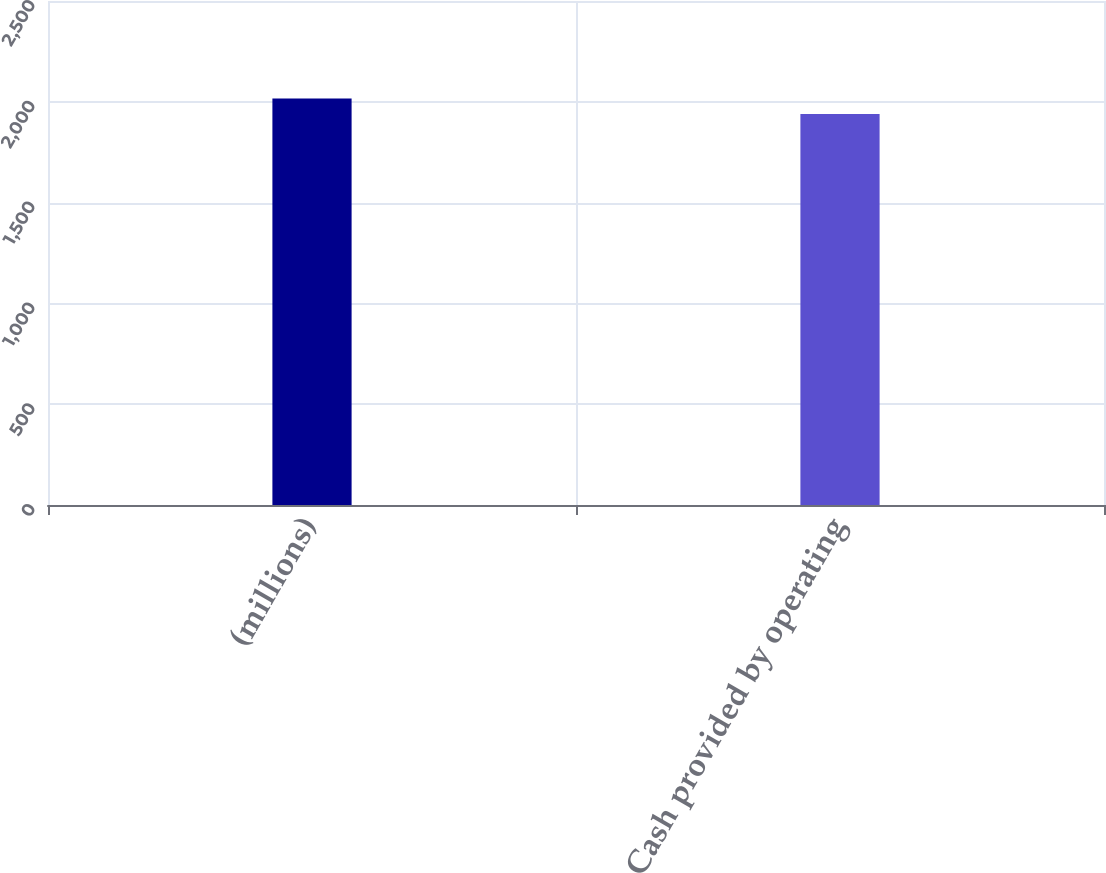Convert chart to OTSL. <chart><loc_0><loc_0><loc_500><loc_500><bar_chart><fcel>(millions)<fcel>Cash provided by operating<nl><fcel>2016<fcel>1939.7<nl></chart> 